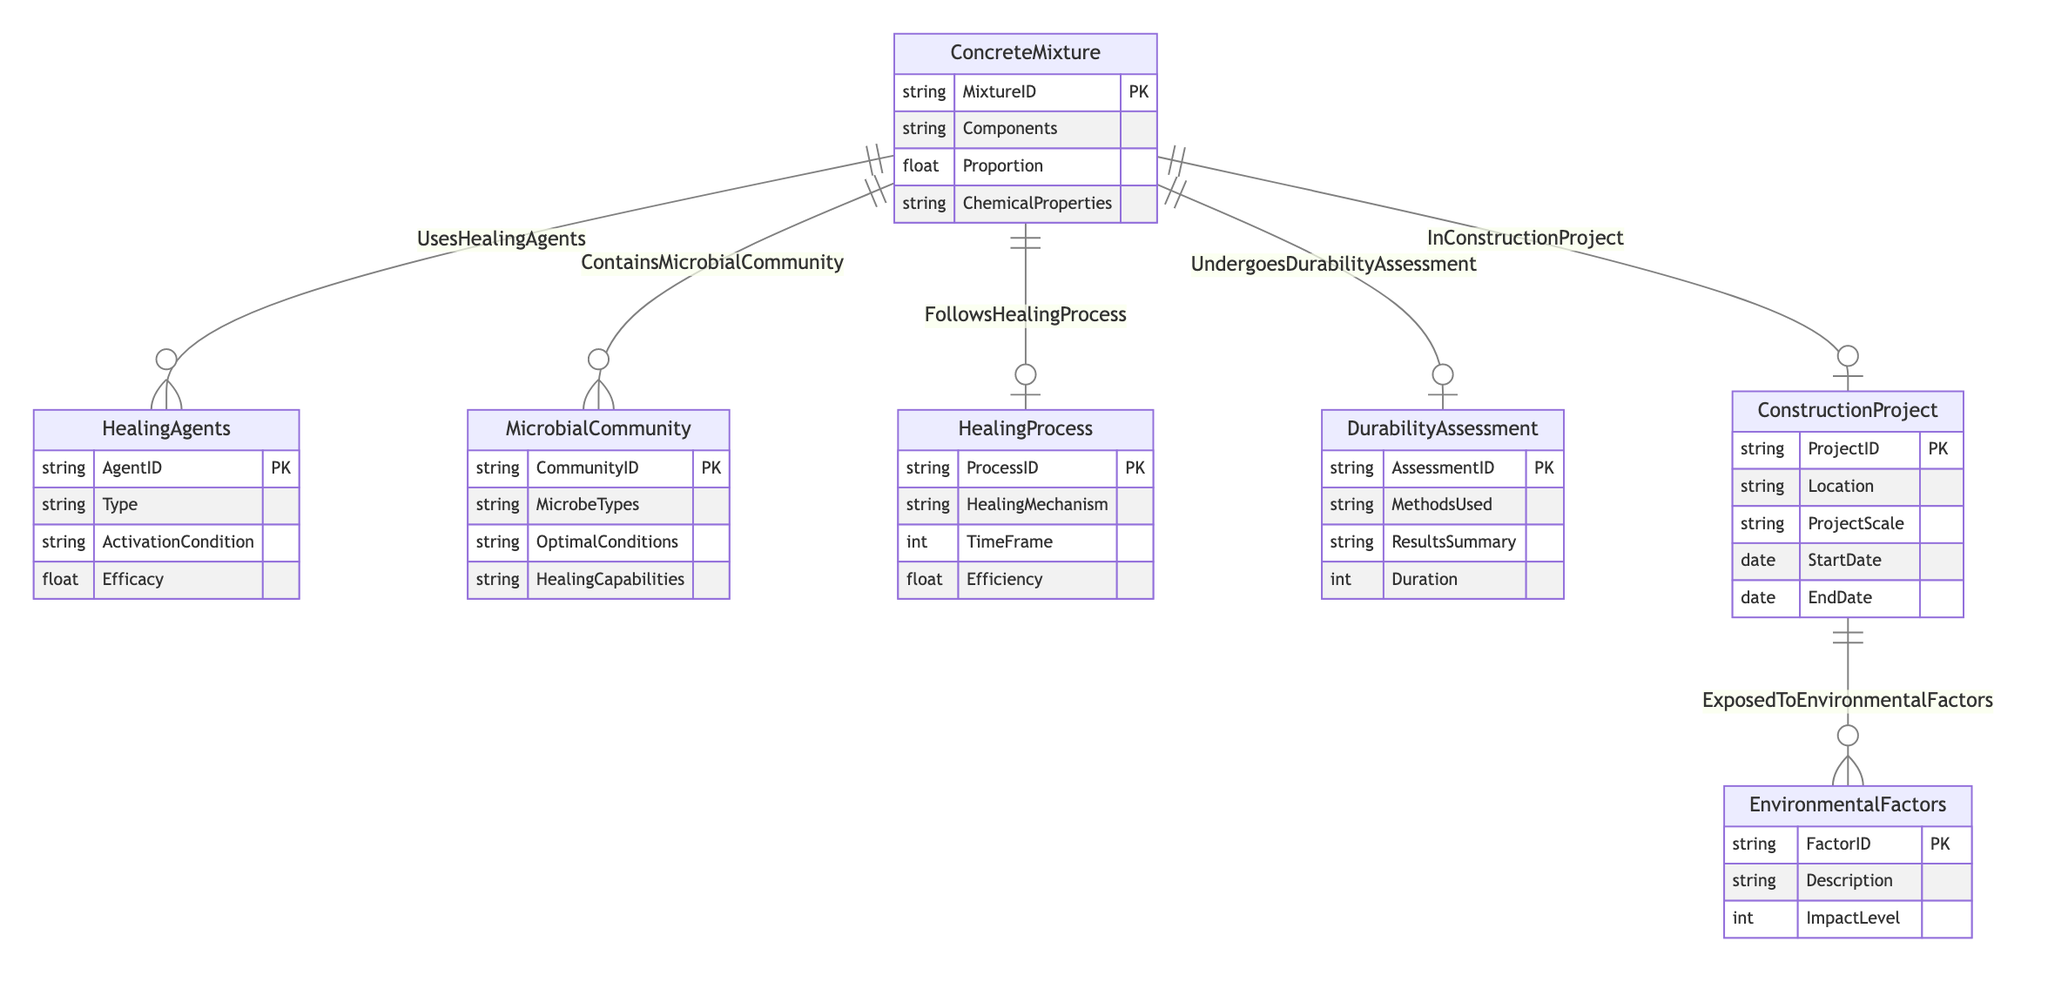What is the primary relationship between ConcreteMixture and HealingAgents? The diagram shows a many-to-many relationship labeled "UsesHealingAgents" between the entities ConcreteMixture and HealingAgents. This indicates that multiple types of healing agents can be used in various concrete mixtures, and one healing agent can be applied to several concrete mixtures.
Answer: Many-to-Many How many attributes does the HealingProcess entity have? By examining the HealingProcess entity in the diagram, it is clear that there are four attributes listed: ProcessID, HealingMechanism, TimeFrame, and Efficiency. Thus, the total count of attributes for the HealingProcess entity is four.
Answer: Four Which entity is linked to both EnvironmentalFactors and ConstructionProject? The diagram reveals that ConstructionProject is connected to EnvironmentalFactors through the many-to-many relationship "ExposedToEnvironmentalFactors." Therefore, while both of these entities are related, it is clear that ConstructionProject serves as the connecting point between them.
Answer: ConstructionProject What is the usage proportion attribute for the relationship between ConcreteMixture and HealingAgents? The usage proportion is an attribute specific to the relationship between ConcreteMixture and HealingAgents labeled "UsesHealingAgents." This indicates that within this relationship, each concrete mixture can specify a usage proportion for each healing agent it employs.
Answer: UsageProportion How many entities in the diagram have a one-to-many relationship? Reviewing the diagram layout shows that the relationships “FollowsHealingProcess,” “UndergoesDurabilityAssessment,” and “InConstructionProject” are all one-to-many relationships, indicating that several concrete mixtures can follow one healing process, undergo one durability assessment, and belong to one construction project respectively. Since there are three such relationships, the answer reflects that there are three entities with one-to-many relationships.
Answer: Three What type of healing agent has the highest efficacy? To answer this question, one would need to visually compare the efficacy values of different agents listed under the HealingAgents entity in the diagram. However, the Efficacy attribute suggests that this information would typically be provided in the dataset accompanying the diagram, leading to the conclusion that without this specific dataset, the precise answer can't be determined solely from the diagram itself.
Answer: Not determinable What type of organisms are included in the MicrobialCommunity entity? The MicrobialCommunity entity specifically has an attribute called MicrobeTypes, which refers to the various types of microbes that can be present in the microbial community. Thus, this directly explains what kind of organisms are represented here.
Answer: Microbes How are environmental factors assessed in construction projects? The relationship between ConstructionProject and EnvironmentalFactors indicates that various environmental factors impacting construction projects are assessed through the attributes ExposureLevel and Duration, which suggest how environmental aspects are measured and the duration of their impact in a given construction scenario.
Answer: ExposureLevel and Duration 